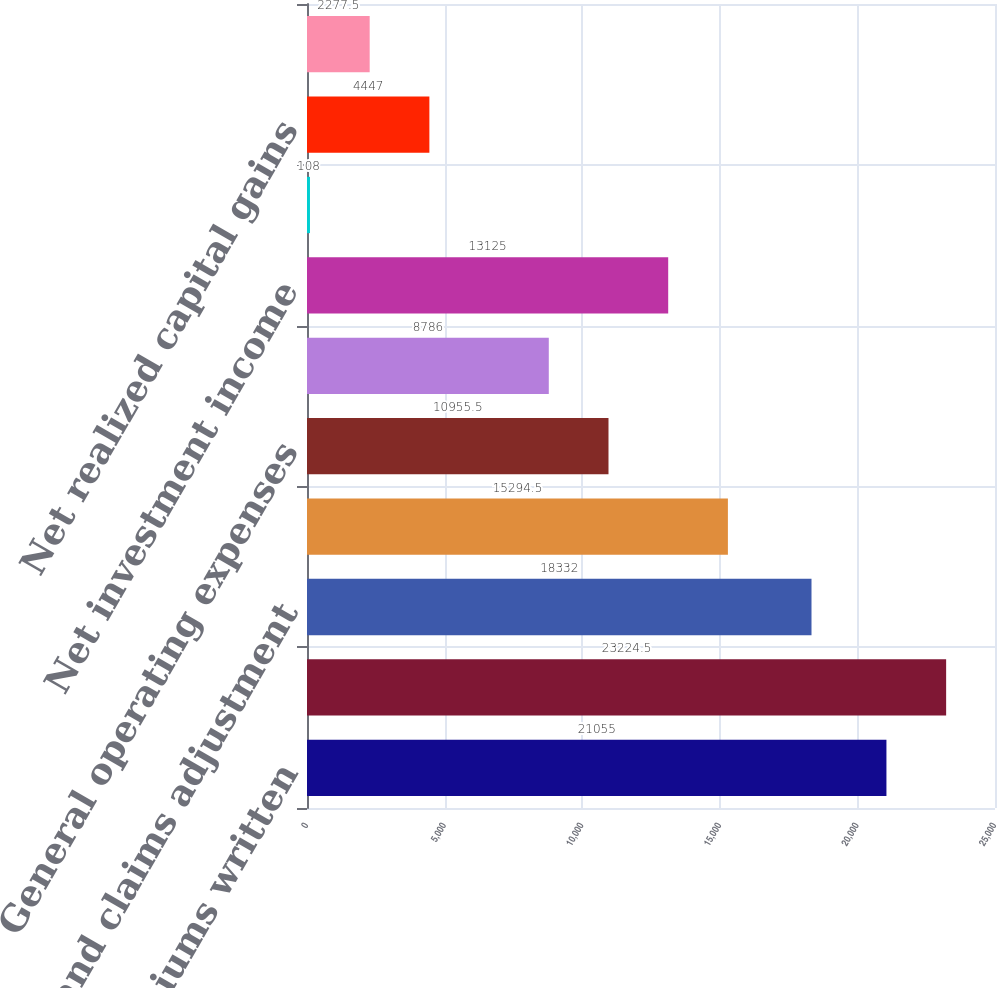<chart> <loc_0><loc_0><loc_500><loc_500><bar_chart><fcel>Net premiums written<fcel>Net premiums earned<fcel>Claims and claims adjustment<fcel>Acquisition expenses<fcel>General operating expenses<fcel>Underwriting loss<fcel>Net investment income<fcel>Decrease in unearned premiums<fcel>Net realized capital gains<fcel>Pre-tax income<nl><fcel>21055<fcel>23224.5<fcel>18332<fcel>15294.5<fcel>10955.5<fcel>8786<fcel>13125<fcel>108<fcel>4447<fcel>2277.5<nl></chart> 